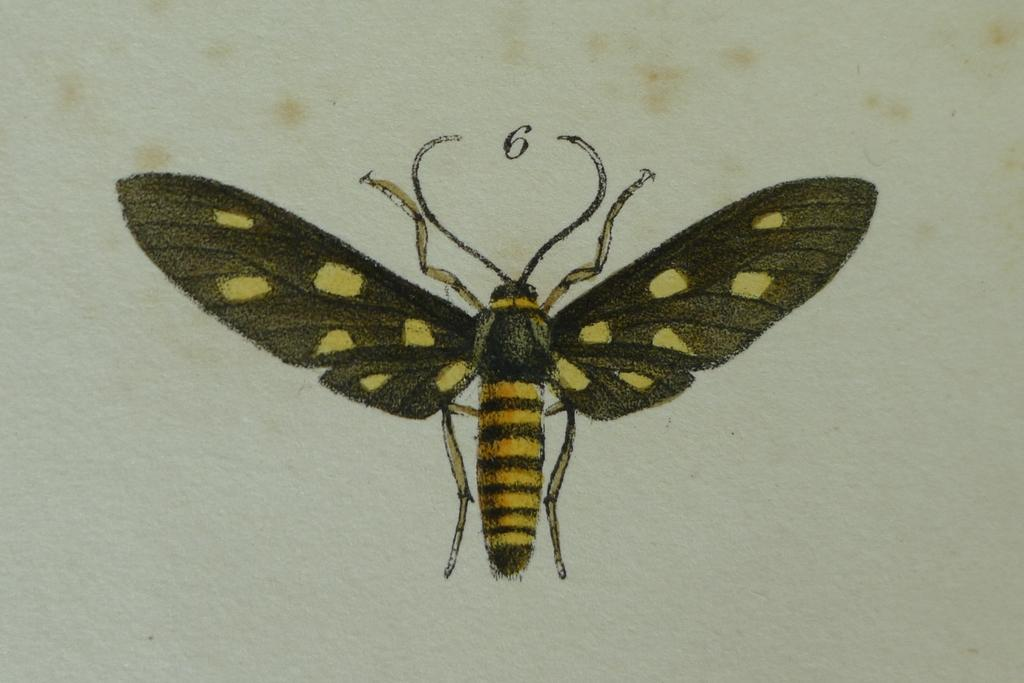What is depicted in the image? There is a sketch of a fly in the image. What is the medium of the sketch? The sketch is on a paper. What type of bridge can be seen in the background of the image? There is no bridge present in the image; it only contains a sketch of a fly on a paper. 